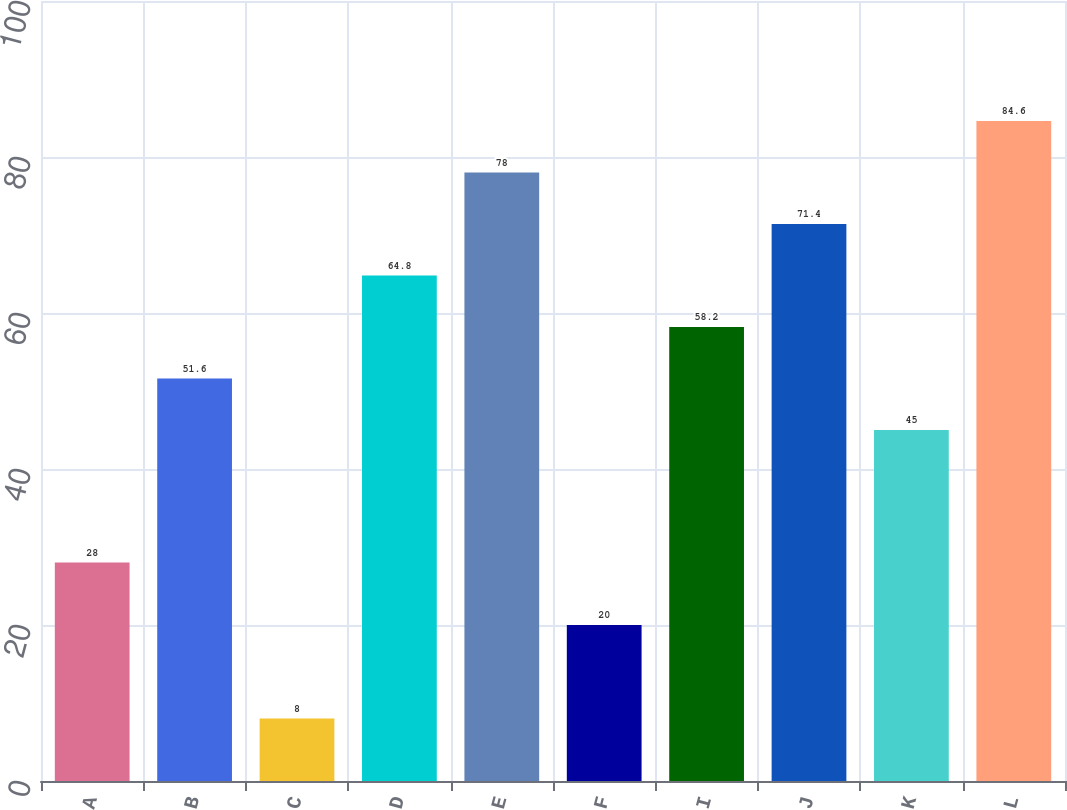Convert chart. <chart><loc_0><loc_0><loc_500><loc_500><bar_chart><fcel>A<fcel>B<fcel>C<fcel>D<fcel>E<fcel>F<fcel>I<fcel>J<fcel>K<fcel>L<nl><fcel>28<fcel>51.6<fcel>8<fcel>64.8<fcel>78<fcel>20<fcel>58.2<fcel>71.4<fcel>45<fcel>84.6<nl></chart> 